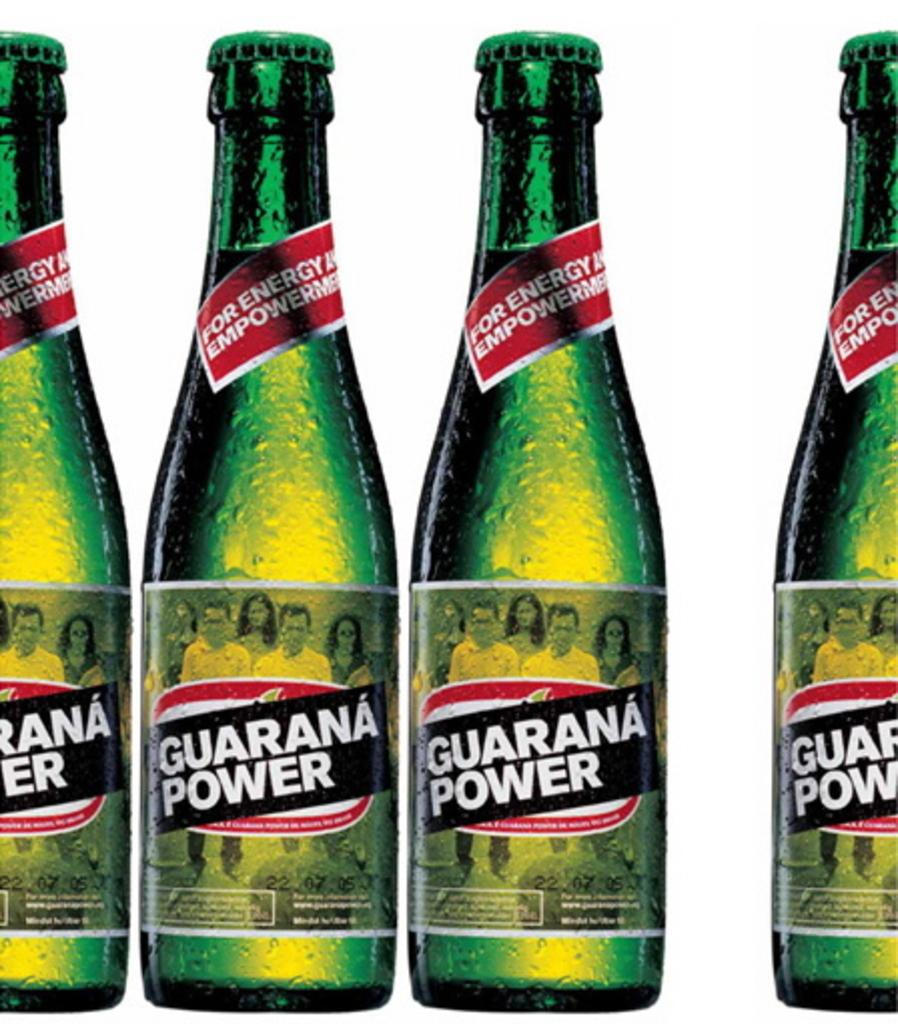<image>
Present a compact description of the photo's key features. Four bottles of Guarana Power sit next to each other. 